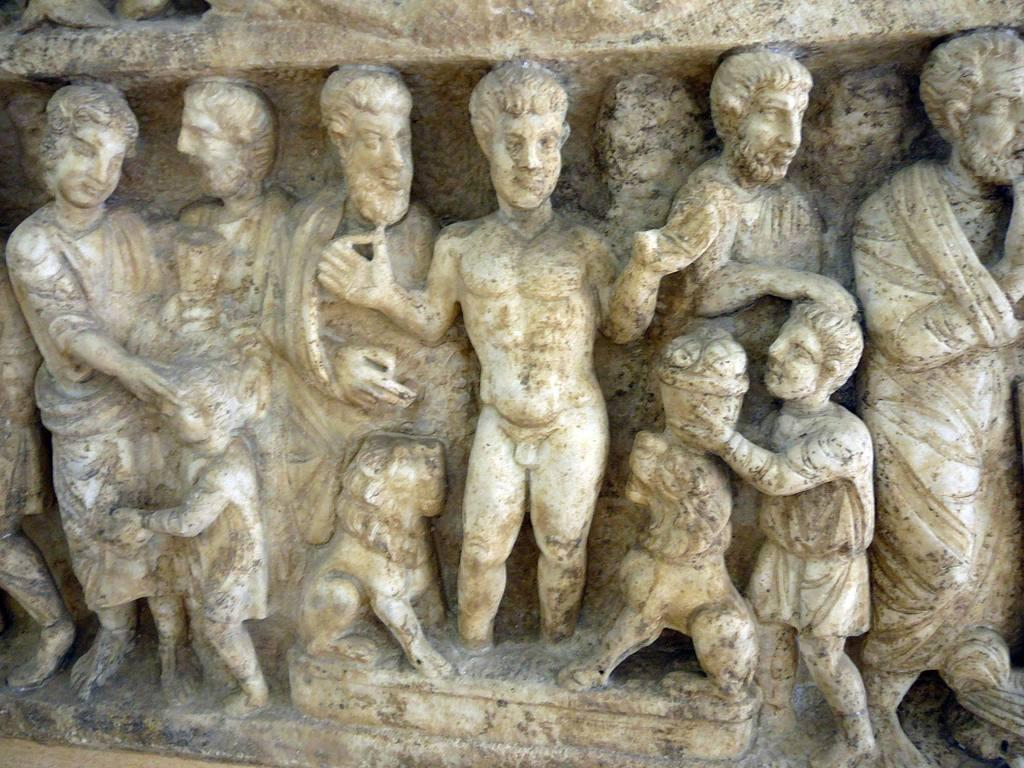What type of artwork can be seen on the wall in the image? There are sculptures on the wall in the image. Can you describe the sculptures in more detail? Unfortunately, the image does not provide enough detail to describe the sculptures further. What might be the purpose of displaying these sculptures on the wall? The purpose of displaying the sculptures could be for decoration or to showcase the artist's work. How much interest is being charged on the payment for the sculptures in the image? There is no information about payment or interest in the image, as it only shows sculptures on the wall. 